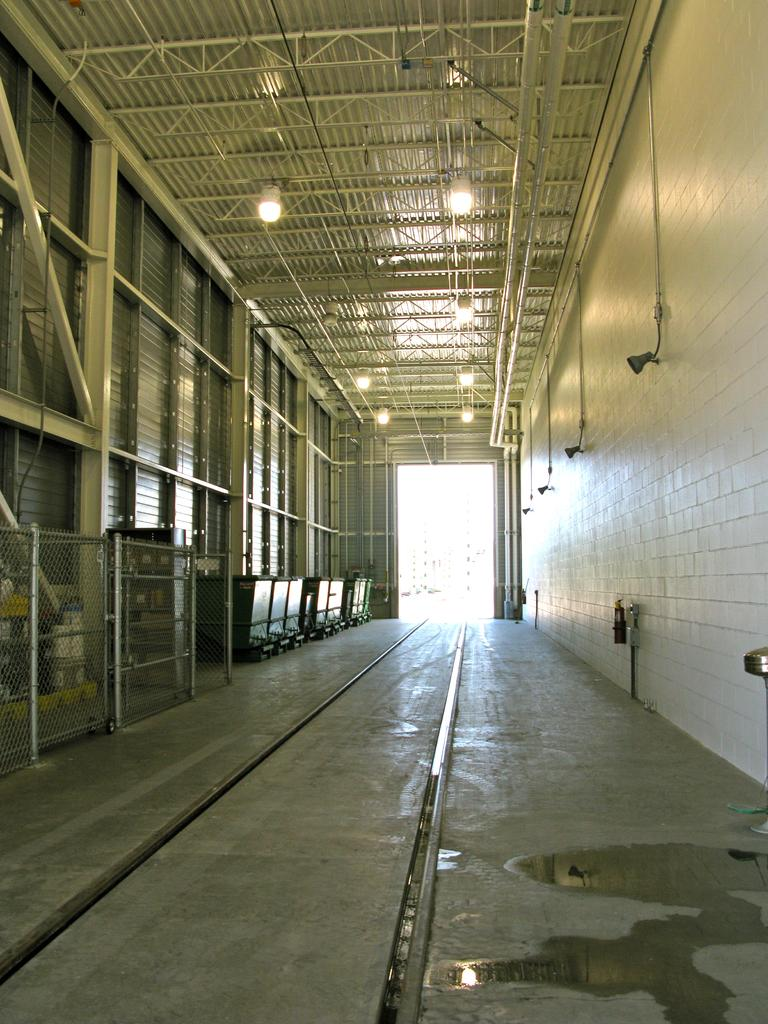What is the main feature of the image? There is a track in the image. What else can be seen near the track? There are poles and lights above the track. Are there any other objects or features in the image? Yes, there are other objects in the left corner of the image. What type of animal can be seen interacting with the track in the image? There is no animal present in the image, and therefore no such interaction can be observed. What body part of the person is visible in the image? There is no person present in the image, so no body parts can be seen. 